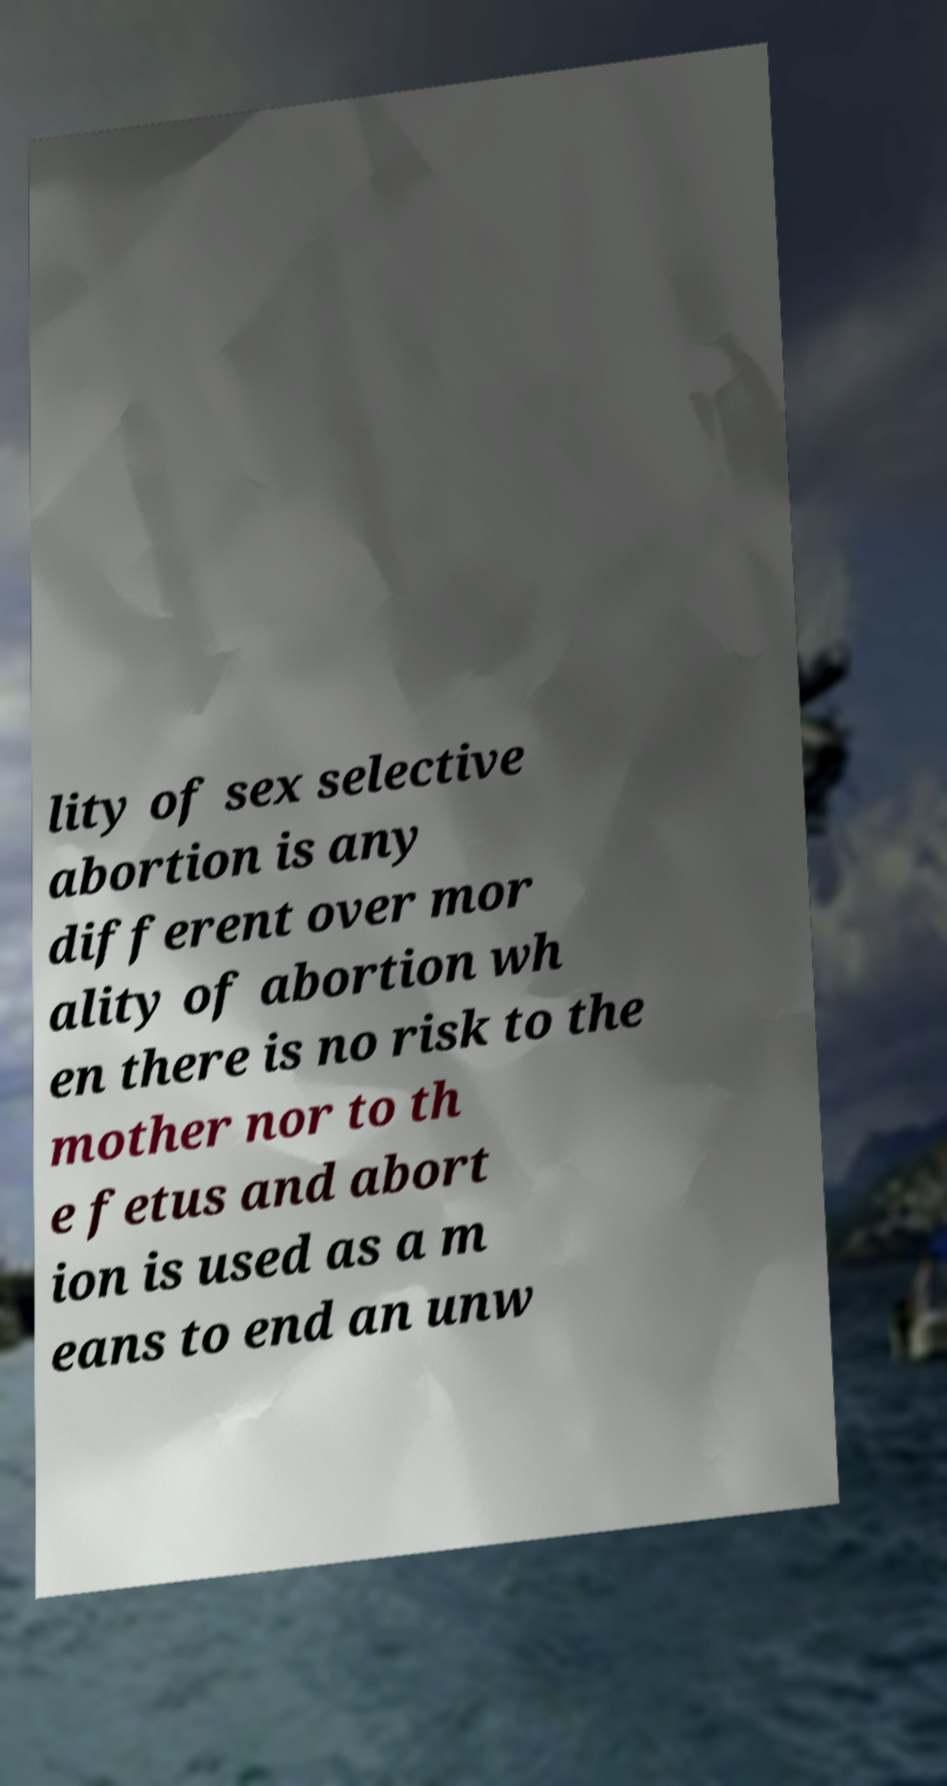What messages or text are displayed in this image? I need them in a readable, typed format. lity of sex selective abortion is any different over mor ality of abortion wh en there is no risk to the mother nor to th e fetus and abort ion is used as a m eans to end an unw 